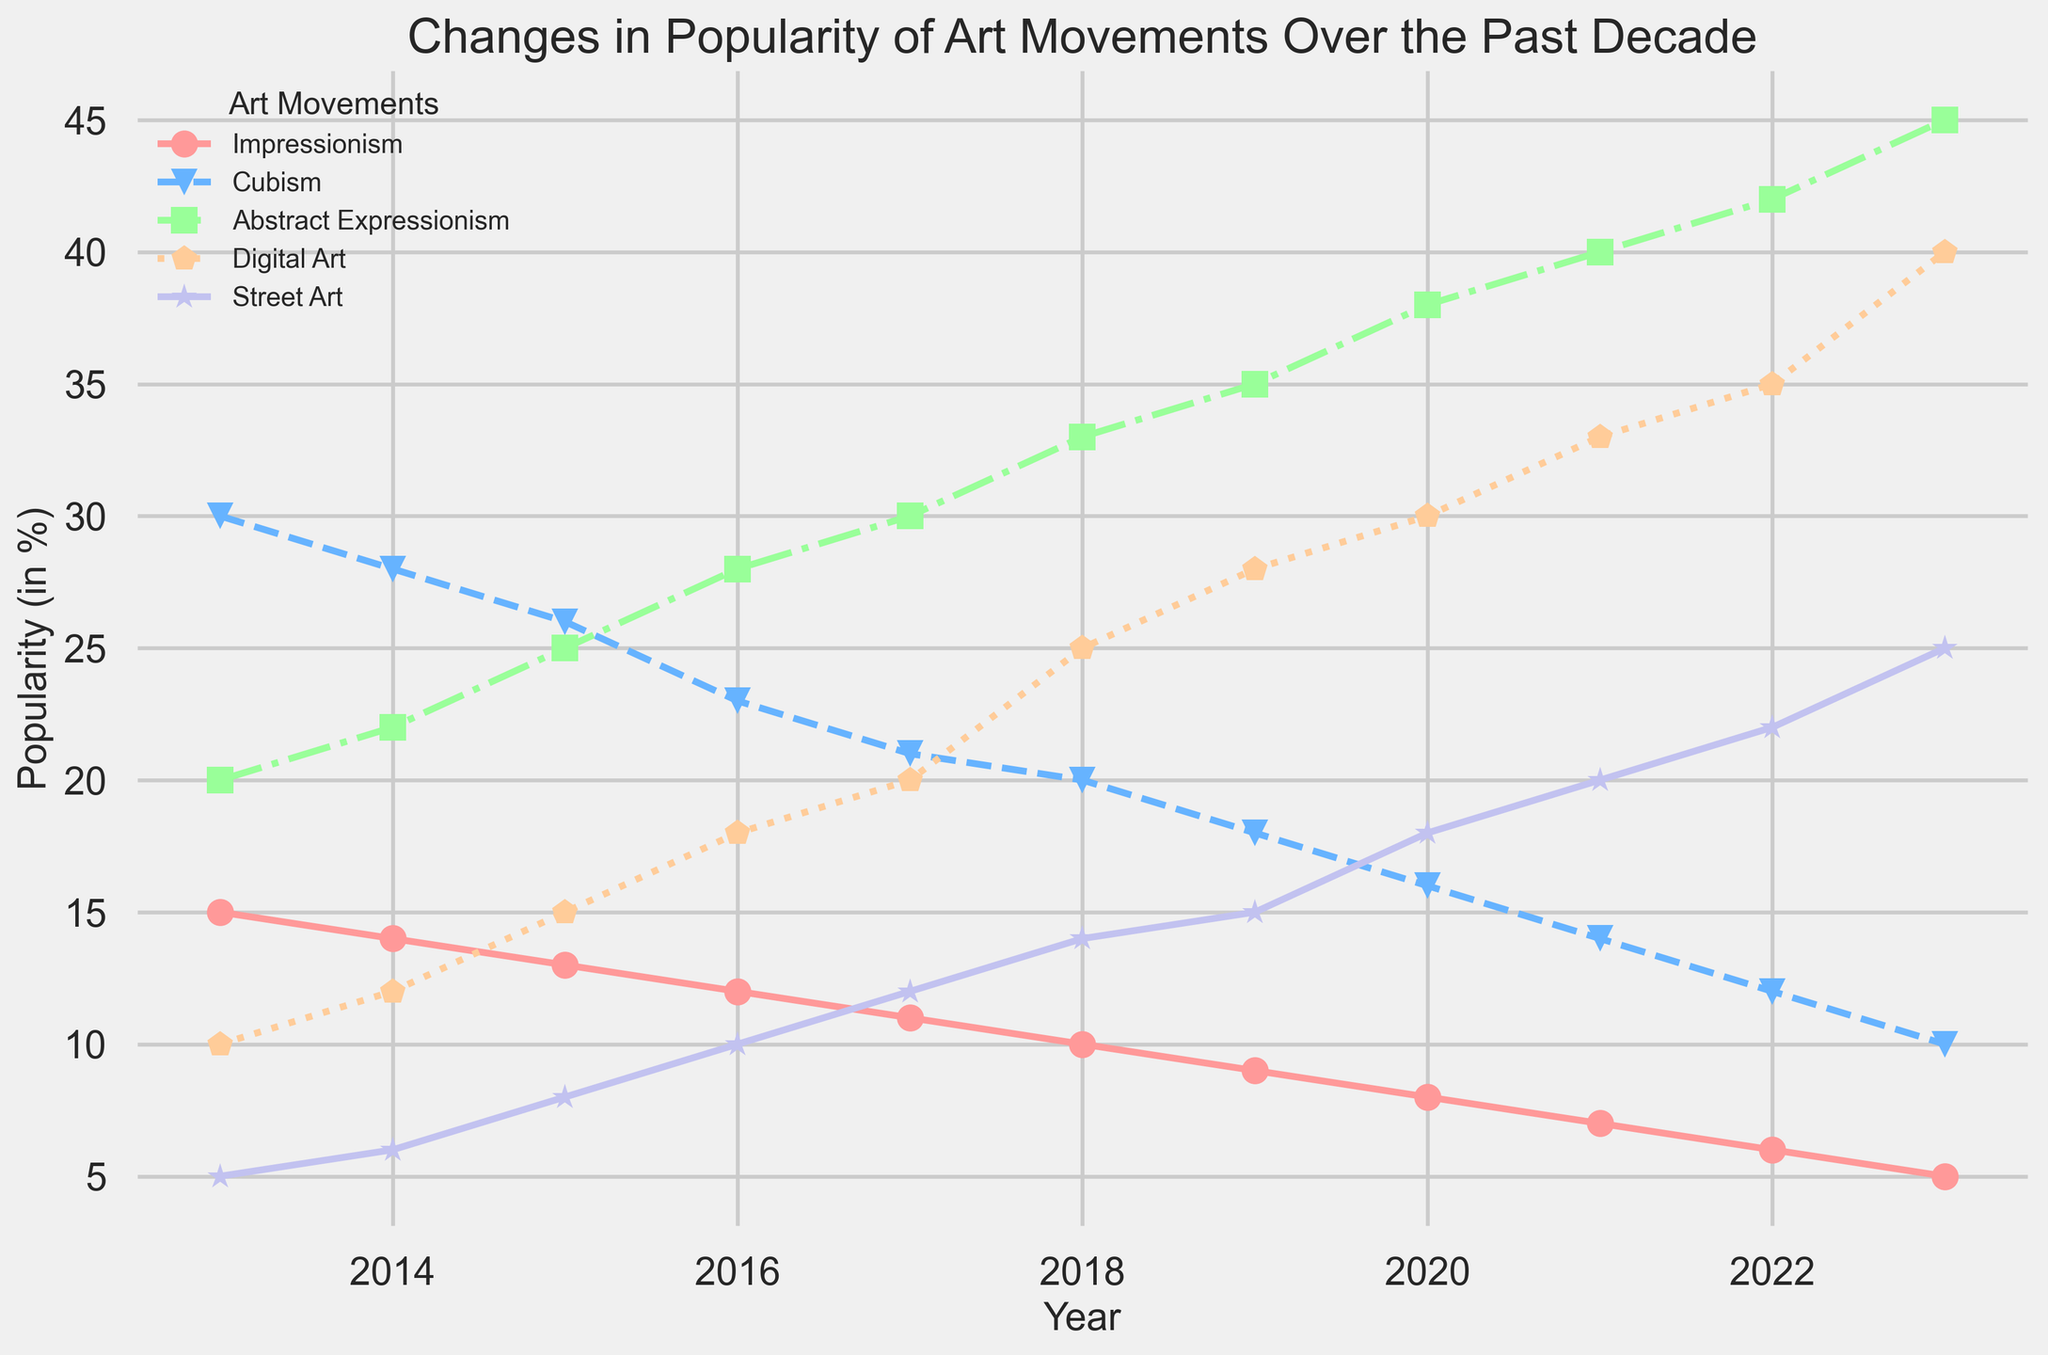Which art movement has seen the most dramatic increase in popularity over the past decade? To determine the most dramatic increase, we need to look for the art movement that has climbed the steepest over the 10-year period. Digital Art starts at 10% popularity in 2013 and rises to 40% in 2023, representing a 30% increase. This is the largest increase among all the art movements.
Answer: Digital Art Which art movement showed a steady decline in popularity throughout the decade? By examining the trends, we can see that Impressionism decreases consistently every year from 15% in 2013 to 5% in 2023.
Answer: Impressionism In which year did Cubism and Street Art hold equal popularity? To find the year when Cubism and Street Art had equal popularity, we observe their data points. Both had a popularity of 10% in 2023.
Answer: 2023 How much did Street Art's popularity increase between 2014 and 2021? The popularity of Street Art in 2014 was 6%, and in 2021 it was 20%. The difference can be calculated by 20% - 6% = 14%.
Answer: 14% Compare the popularity trends of Abstract Expressionism and Digital Art. Which movement had a greater total increase in popularity from 2013 to 2023 and by how much? Abstract Expressionism increased from 20% to 45% which is a 25% increase. Digital Art increased from 10% to 40% which is a 30% increase. Therefore, Digital Art had a greater total increase by 5% more than Abstract Expressionism.
Answer: Digital Art, 5% Which art movement remained consistently less popular than Cubism throughout the decade? By looking at the data, we can see that Street Art started less popular than Cubism and caught up by the end of the decade. Impressionism shows a steady decline and is consistently less popular than Cubism.
Answer: Impressionism What is the combined popularity percentage of Abstract Expressionism and Digital Art in 2023? In 2023, Abstract Expressionism is at 45% and Digital Art is at 40%. Their combined popularity would be 45% + 40% = 85%.
Answer: 85% Between 2017 and 2022, which art movement showed the least change in popularity? Abstract Expressionism went from 30% in 2017 to 42% in 2022, a 12% change. Impressionism declined from 11% to 6%, a 5% change. Digital Art rose from 20% to 35%, a 15% change. Cubism decreased from 21% to 12%, a 9% change, and Street Art increased from 12% to 22%, a 10% change. Thus, Impressionism showed the least change with a 5% decline.
Answer: Impressionism 